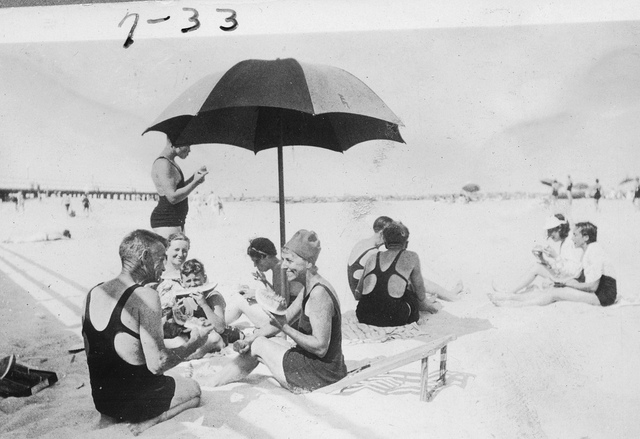Extract all visible text content from this image. 7 3 3 